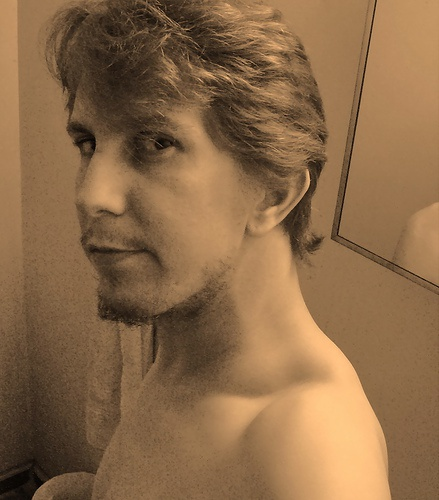Describe the objects in this image and their specific colors. I can see people in tan, gray, and maroon tones in this image. 